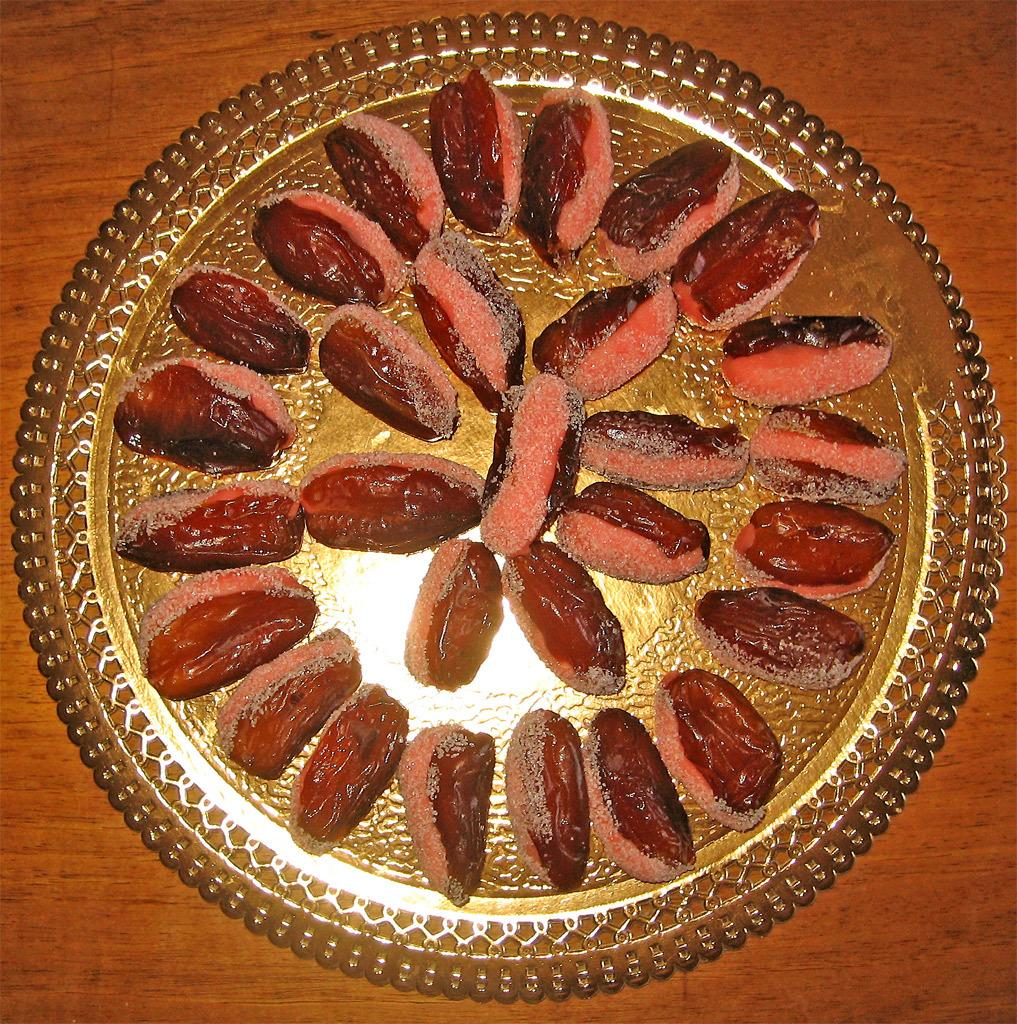What is on the plate that is visible in the image? There are food items on a plate in the image. Where is the plate located in the image? The plate is placed on a table. What type of voice can be heard coming from the sink in the image? There is no sink present in the image, and therefore no voice can be heard coming from it. 